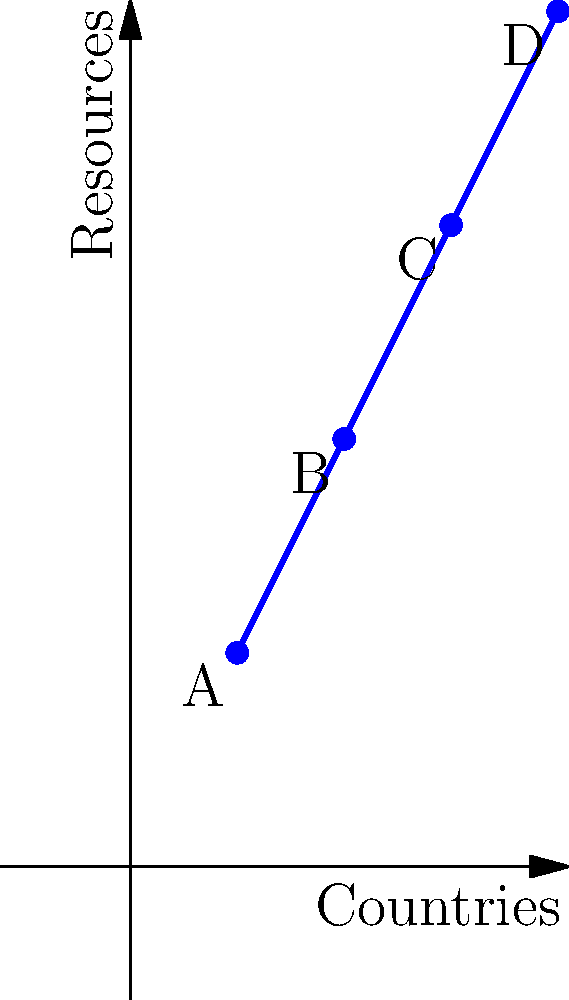The graph represents the spread of online language resources across different countries. If the vector $\vec{v} = \begin{pmatrix} 1 \\ 2 \end{pmatrix}$ represents the increase in resources from one country to the next, what scalar $k$ should multiply $\vec{v}$ to reach point D from point A? To solve this problem, we need to follow these steps:

1. Identify the coordinates of points A and D:
   Point A: $(1, 2)$
   Point D: $(4, 8)$

2. Calculate the vector from A to D:
   $\vec{AD} = \begin{pmatrix} 4-1 \\ 8-2 \end{pmatrix} = \begin{pmatrix} 3 \\ 6 \end{pmatrix}$

3. We know that $\vec{v} = \begin{pmatrix} 1 \\ 2 \end{pmatrix}$, and we need to find $k$ such that $k\vec{v} = \vec{AD}$

4. Set up the equation:
   $k\begin{pmatrix} 1 \\ 2 \end{pmatrix} = \begin{pmatrix} 3 \\ 6 \end{pmatrix}$

5. This gives us two equations:
   $k \cdot 1 = 3$
   $k \cdot 2 = 6$

6. Solving either equation gives us $k = 3$

7. Verify: $3\begin{pmatrix} 1 \\ 2 \end{pmatrix} = \begin{pmatrix} 3 \\ 6 \end{pmatrix}$, which matches $\vec{AD}$
Answer: $k = 3$ 